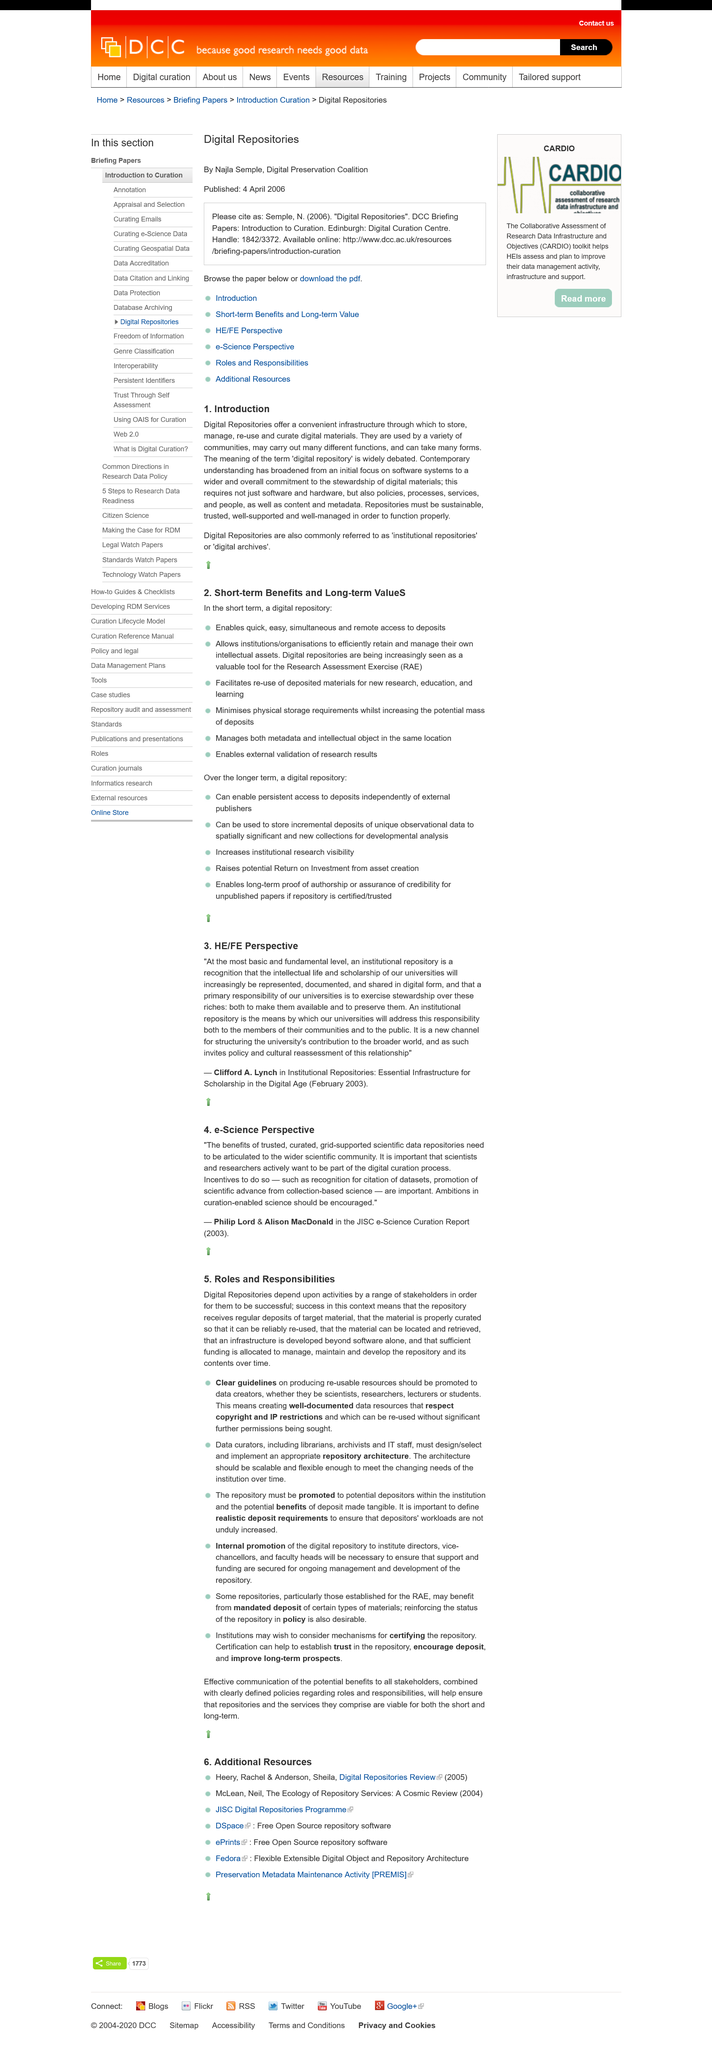Draw attention to some important aspects in this diagram. Digital repositories provide a reliable and accessible platform for the storage, management, retrieval, and preservation of digital materials. Institutional repositories" and "digital archives" are common phrases used to refer to digital repositories. Repositories must be sustainable, trusted, well-supported, and well-managed in order to function properly. 